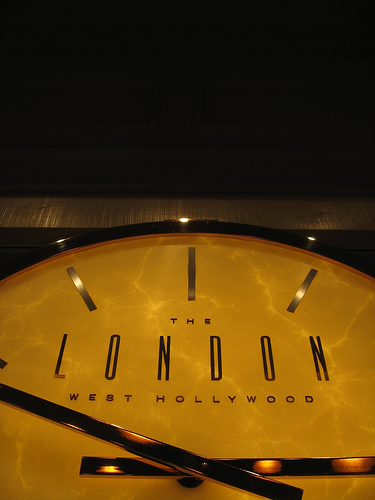Please transcribe the text in this image. THE WEST HOLLYWOOD LONDON 